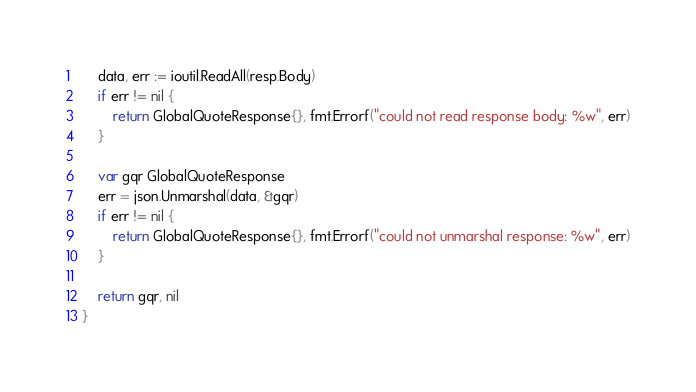Convert code to text. <code><loc_0><loc_0><loc_500><loc_500><_Go_>
	data, err := ioutil.ReadAll(resp.Body)
	if err != nil {
		return GlobalQuoteResponse{}, fmt.Errorf("could not read response body: %w", err)
	}

	var gqr GlobalQuoteResponse
	err = json.Unmarshal(data, &gqr)
	if err != nil {
		return GlobalQuoteResponse{}, fmt.Errorf("could not unmarshal response: %w", err)
	}

	return gqr, nil
}
</code> 